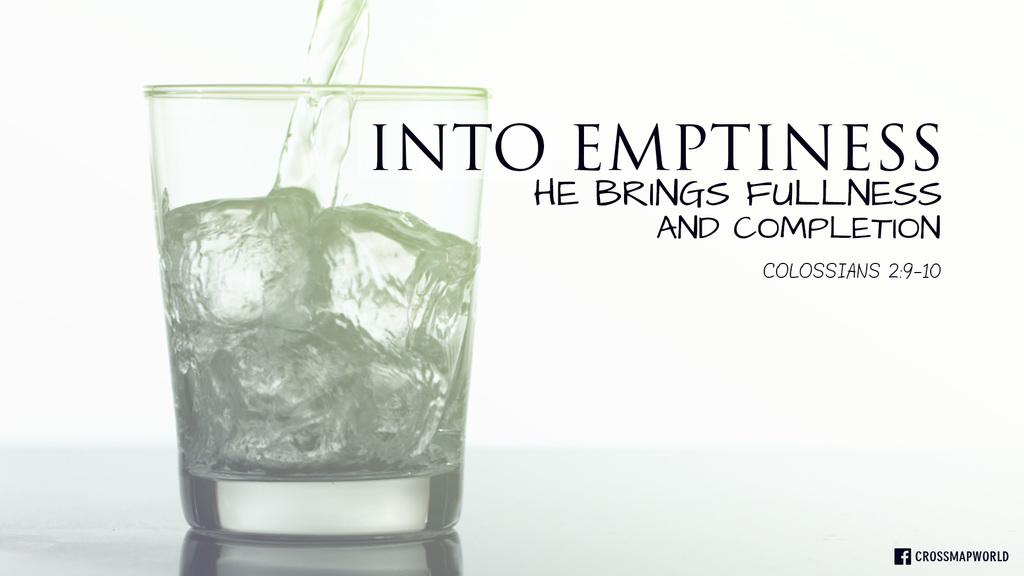<image>
Relay a brief, clear account of the picture shown. a slogan with the word emptiness next to a glass 